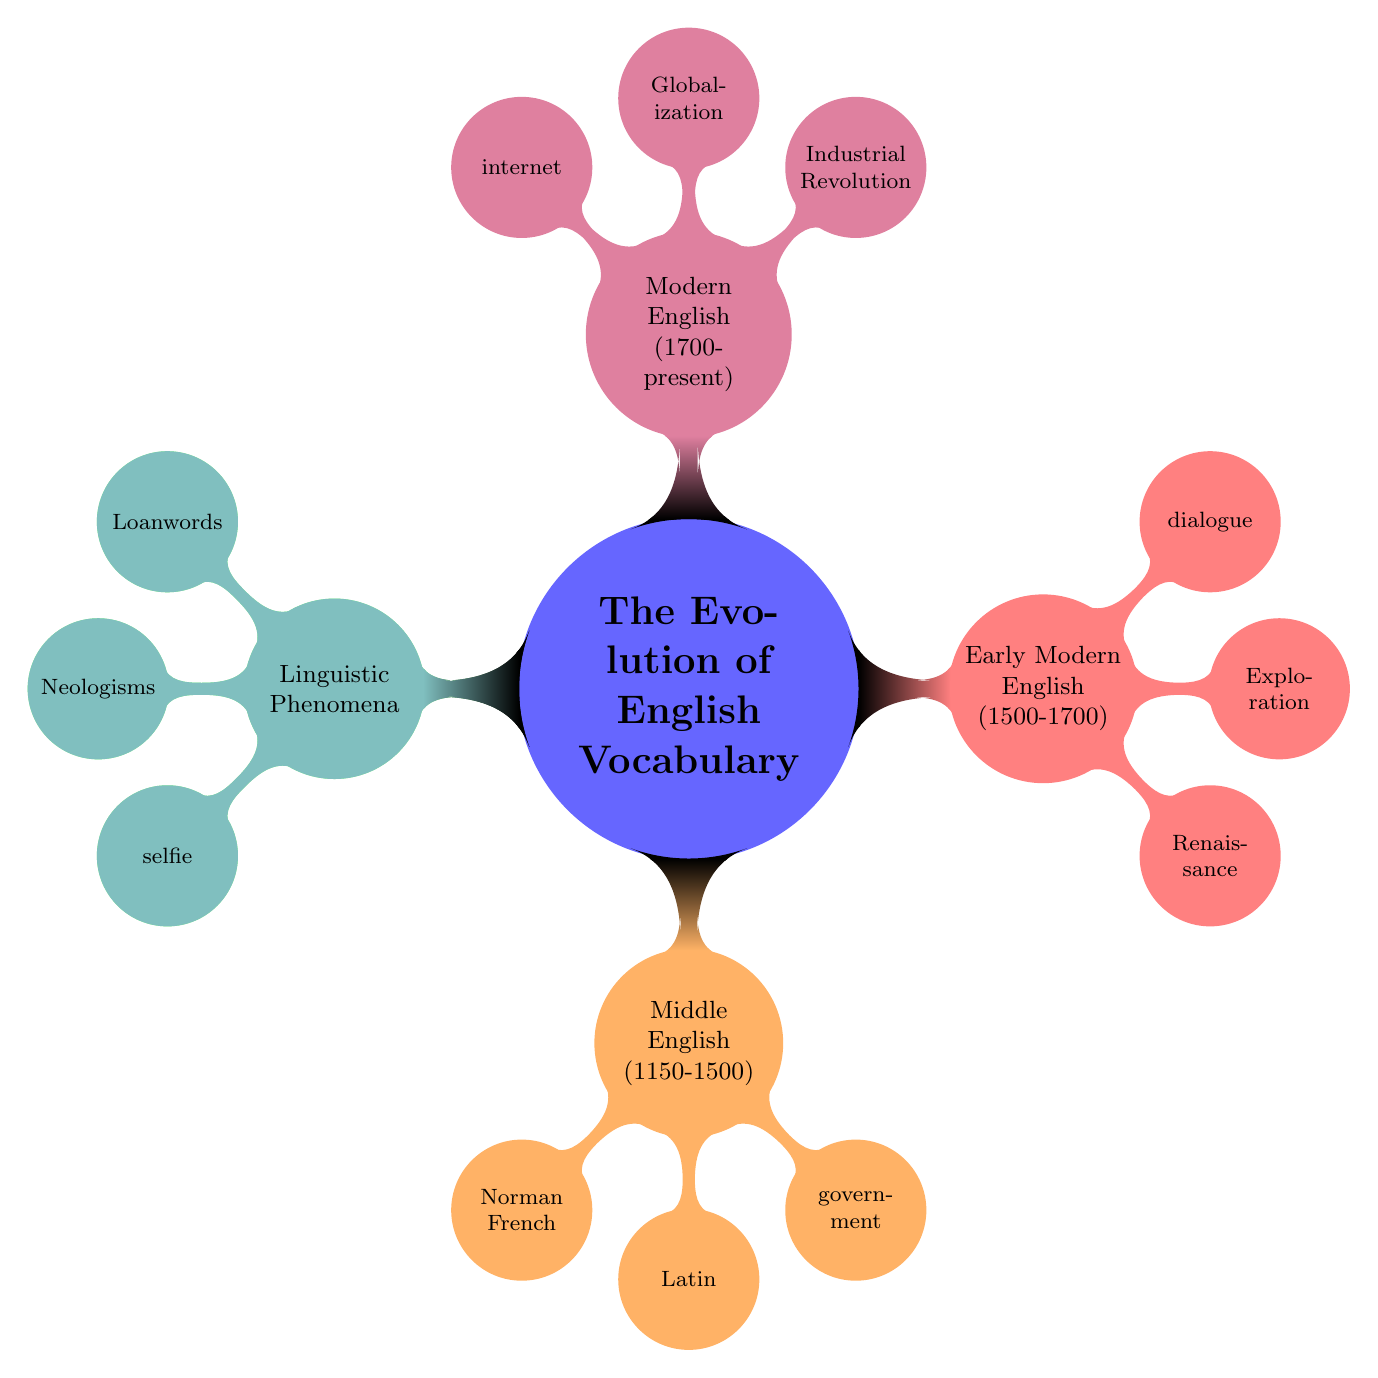What are the two influences on Old English? The diagram shows two branches under the "Old English (450-1150)" node labeled "Anglo-Saxon" and "Norse". These are the influences listed.
Answer: Anglo-Saxon, Norse What examples are provided for Middle English? The node labeled "Middle English (1150-1500)" contains a list with the examples "government" and "justice". These words are directly mentioned.
Answer: government, justice What is a linguistic phenomenon associated with new words in English? Under the "Linguistic Phenomena" node, the sub-node labeled "Neologisms" refers to new words, while "selfie" is an example given in that section.
Answer: selfie In which period did the influence of the Renaissance occur? The node for "Early Modern English (1500-1700)" includes "Renaissance" as one of the influences for this period. This is the response directly connected to that node.
Answer: Early Modern English (1500-1700) How many examples are listed under Modern English? The "Modern English (1700-present)" node contains three examples, which are "internet", "software", and the influence nodes are not considered examples. Thus, the count is three.
Answer: 2 What are the influences of Modern English? The diagram details two influences directly under the "Modern English (1700-present)" node: "Industrial Revolution" and "Globalization". These indicate what has shaped vocabulary in this period.
Answer: Industrial Revolution, Globalization Which examples are given for Early Modern English? The "Early Modern English (1500-1700)" node has two examples listed: "dialogue" and "horizon". These words demonstrate vocabulary from that time.
Answer: dialogue, horizon What linguistic phenomenon refers to words borrowed from other languages? The branch for "Linguistic Phenomena" contains the sub-node "Loanwords", which refers to words taken from different languages. It also displays examples like "ballet".
Answer: Loanwords 